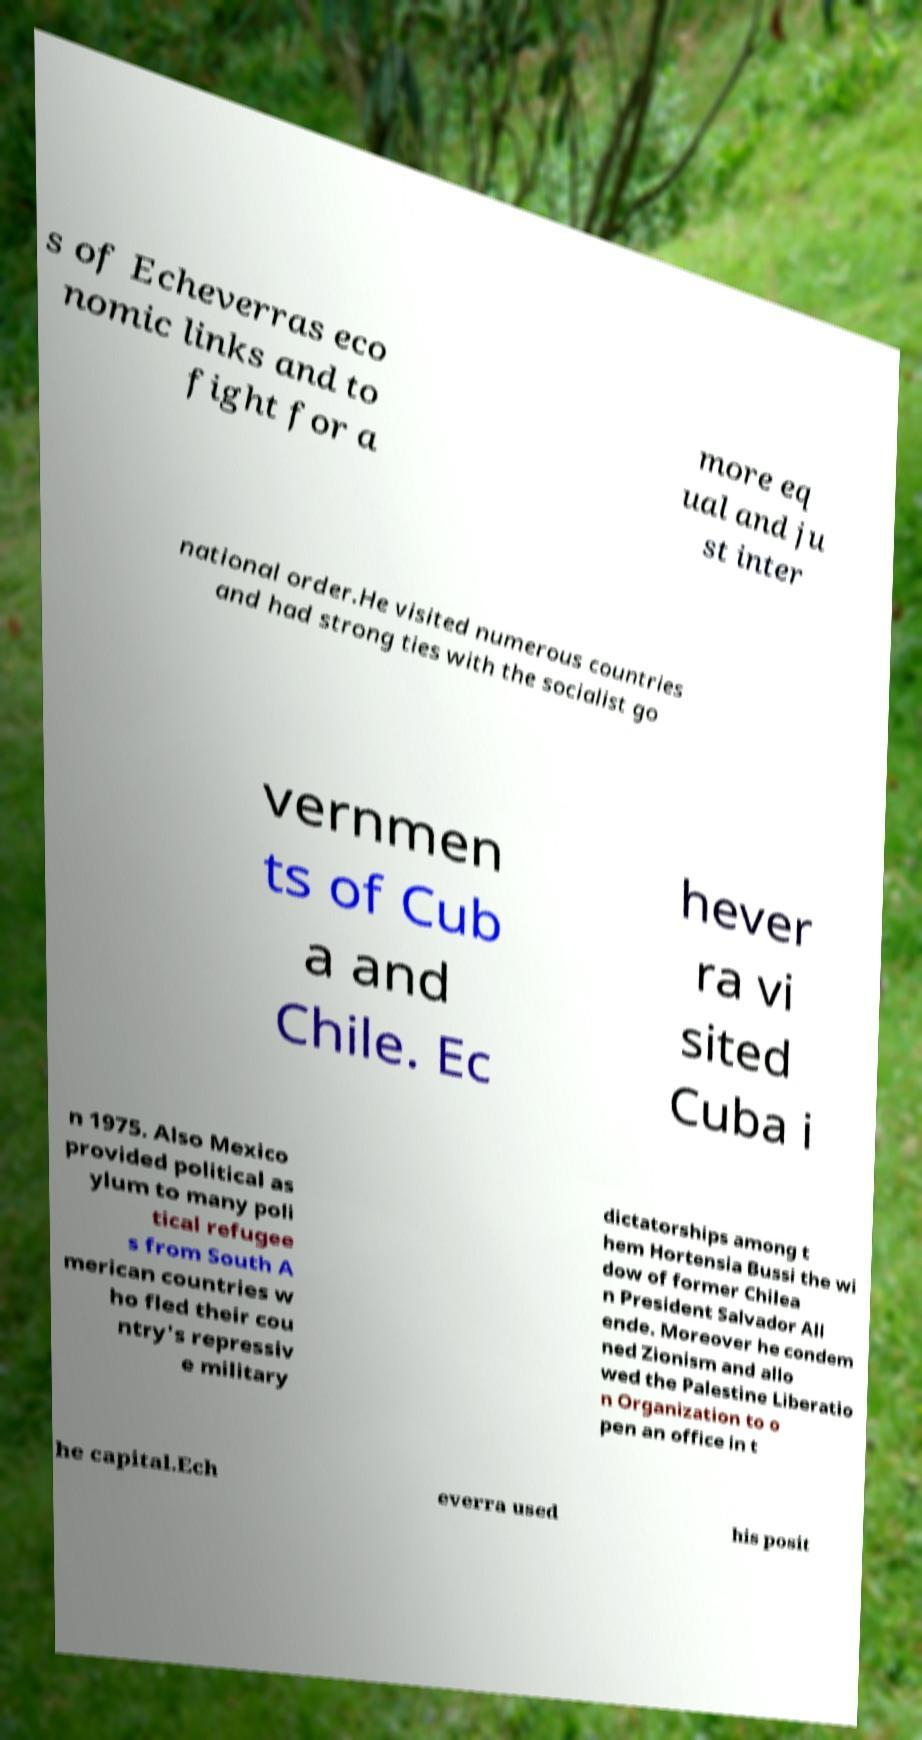Please read and relay the text visible in this image. What does it say? s of Echeverras eco nomic links and to fight for a more eq ual and ju st inter national order.He visited numerous countries and had strong ties with the socialist go vernmen ts of Cub a and Chile. Ec hever ra vi sited Cuba i n 1975. Also Mexico provided political as ylum to many poli tical refugee s from South A merican countries w ho fled their cou ntry's repressiv e military dictatorships among t hem Hortensia Bussi the wi dow of former Chilea n President Salvador All ende. Moreover he condem ned Zionism and allo wed the Palestine Liberatio n Organization to o pen an office in t he capital.Ech everra used his posit 